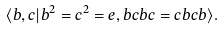<formula> <loc_0><loc_0><loc_500><loc_500>\langle b , c | b ^ { 2 } = c ^ { 2 } = e , b c b c = c b c b \rangle .</formula> 